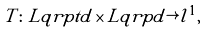Convert formula to latex. <formula><loc_0><loc_0><loc_500><loc_500>T \colon L q r p t d \times L q r p d \rightarrow l ^ { 1 } ,</formula> 